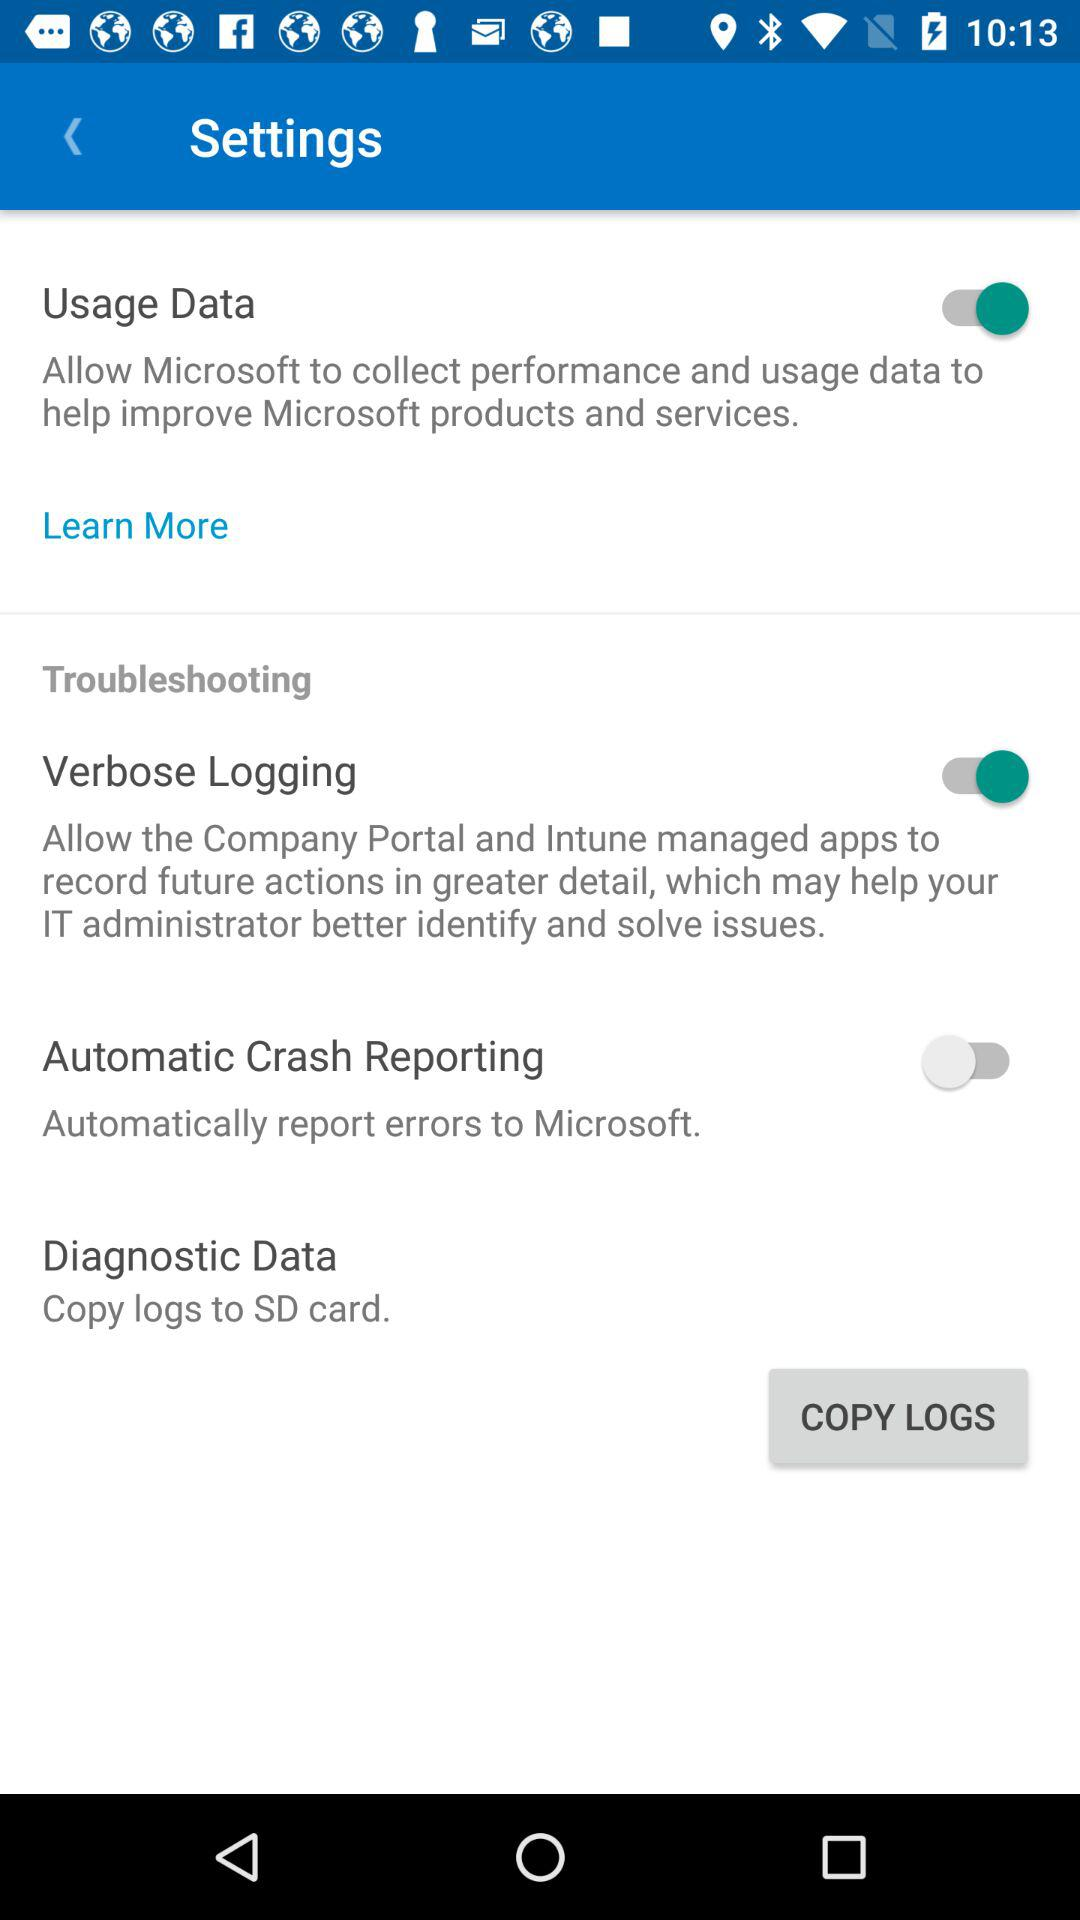What is the status of "Automatic Crash Reporting"? The status is "off". 